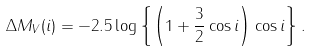Convert formula to latex. <formula><loc_0><loc_0><loc_500><loc_500>\Delta M _ { V } ( i ) = - 2 . 5 \log \left \{ \left ( 1 + \frac { 3 } { 2 } \cos i \right ) \cos i \right \} .</formula> 